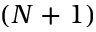<formula> <loc_0><loc_0><loc_500><loc_500>\left ( N + 1 \right )</formula> 